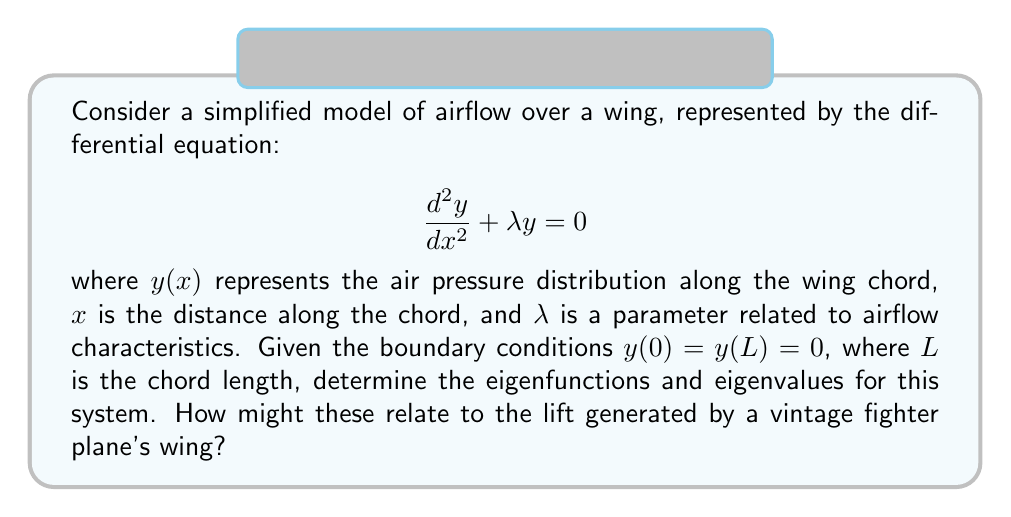What is the answer to this math problem? Let's approach this step-by-step:

1) The given differential equation is a second-order homogeneous equation with constant coefficients. Its general solution is of the form:

   $$y(x) = A \cos(\sqrt{\lambda}x) + B \sin(\sqrt{\lambda}x)$$

2) Applying the boundary conditions:
   
   At $x = 0$: $y(0) = A = 0$
   At $x = L$: $y(L) = B \sin(\sqrt{\lambda}L) = 0$

3) For non-trivial solutions ($B \neq 0$), we must have:

   $$\sin(\sqrt{\lambda}L) = 0$$

4) This is satisfied when $\sqrt{\lambda}L = n\pi$, where $n = 1, 2, 3, ...$

5) Solving for $\lambda$:

   $$\lambda_n = \left(\frac{n\pi}{L}\right)^2, \quad n = 1, 2, 3, ...$$

6) The corresponding eigenfunctions are:

   $$y_n(x) = B_n \sin\left(\frac{n\pi x}{L}\right), \quad n = 1, 2, 3, ...$$

   where $B_n$ are arbitrary constants.

7) These eigenfunctions represent the possible modes of air pressure distribution along the wing chord. The fundamental mode ($n = 1$) corresponds to the basic lift distribution, while higher modes represent more complex pressure patterns.

8) For a vintage fighter plane, the lower modes (especially $n = 1$) would contribute most significantly to lift generation. The eigenvalues $\lambda_n$ are related to the frequencies of pressure oscillations along the wing, which could affect the wing's performance at different airspeeds.
Answer: Eigenfunctions: $y_n(x) = B_n \sin\left(\frac{n\pi x}{L}\right)$, Eigenvalues: $\lambda_n = \left(\frac{n\pi}{L}\right)^2$, $n = 1, 2, 3, ...$ 